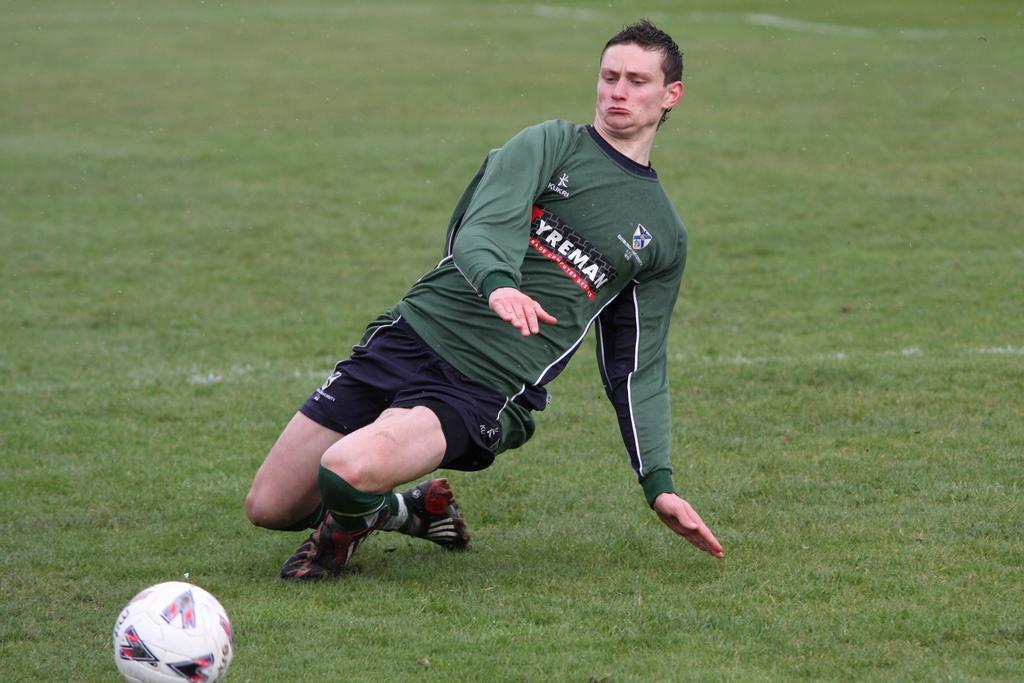In one or two sentences, can you explain what this image depicts? In this image I can see the person and the person is wearing green and black color dress. In front I can see the ball and the grass is in green color. 